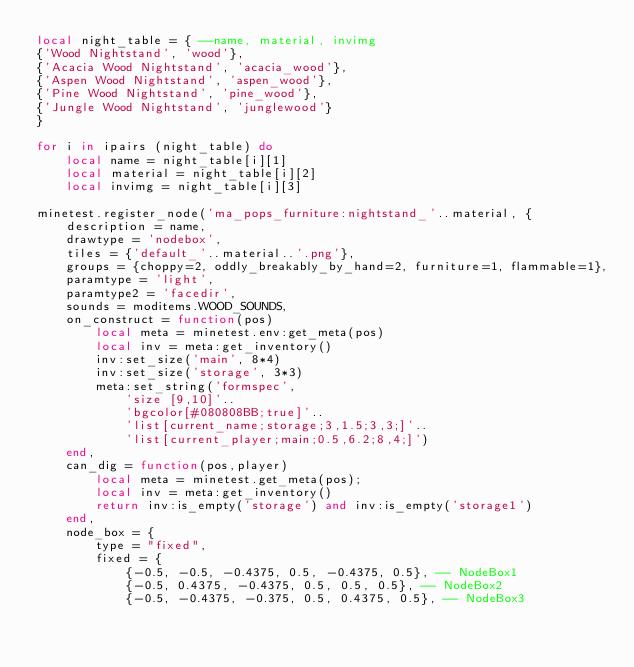<code> <loc_0><loc_0><loc_500><loc_500><_Lua_>local night_table = { --name, material, invimg
{'Wood Nightstand', 'wood'},
{'Acacia Wood Nightstand', 'acacia_wood'},
{'Aspen Wood Nightstand', 'aspen_wood'},
{'Pine Wood Nightstand', 'pine_wood'},
{'Jungle Wood Nightstand', 'junglewood'}
}

for i in ipairs (night_table) do
	local name = night_table[i][1]
	local material = night_table[i][2]
	local invimg = night_table[i][3]

minetest.register_node('ma_pops_furniture:nightstand_'..material, {
	description = name,
	drawtype = 'nodebox',
	tiles = {'default_'..material..'.png'},
	groups = {choppy=2, oddly_breakably_by_hand=2, furniture=1, flammable=1},
	paramtype = 'light',
	paramtype2 = 'facedir',
	sounds = moditems.WOOD_SOUNDS,
	on_construct = function(pos)
		local meta = minetest.env:get_meta(pos)
		local inv = meta:get_inventory()
		inv:set_size('main', 8*4)
		inv:set_size('storage', 3*3)
		meta:set_string('formspec',
			'size [9,10]'..
			'bgcolor[#080808BB;true]'..
			'list[current_name;storage;3,1.5;3,3;]'..
			'list[current_player;main;0.5,6.2;8,4;]')
	end,
	can_dig = function(pos,player)
		local meta = minetest.get_meta(pos);
		local inv = meta:get_inventory()
		return inv:is_empty('storage') and inv:is_empty('storage1')
	end,
	node_box = {
		type = "fixed",
		fixed = {
			{-0.5, -0.5, -0.4375, 0.5, -0.4375, 0.5}, -- NodeBox1
			{-0.5, 0.4375, -0.4375, 0.5, 0.5, 0.5}, -- NodeBox2
			{-0.5, -0.4375, -0.375, 0.5, 0.4375, 0.5}, -- NodeBox3</code> 